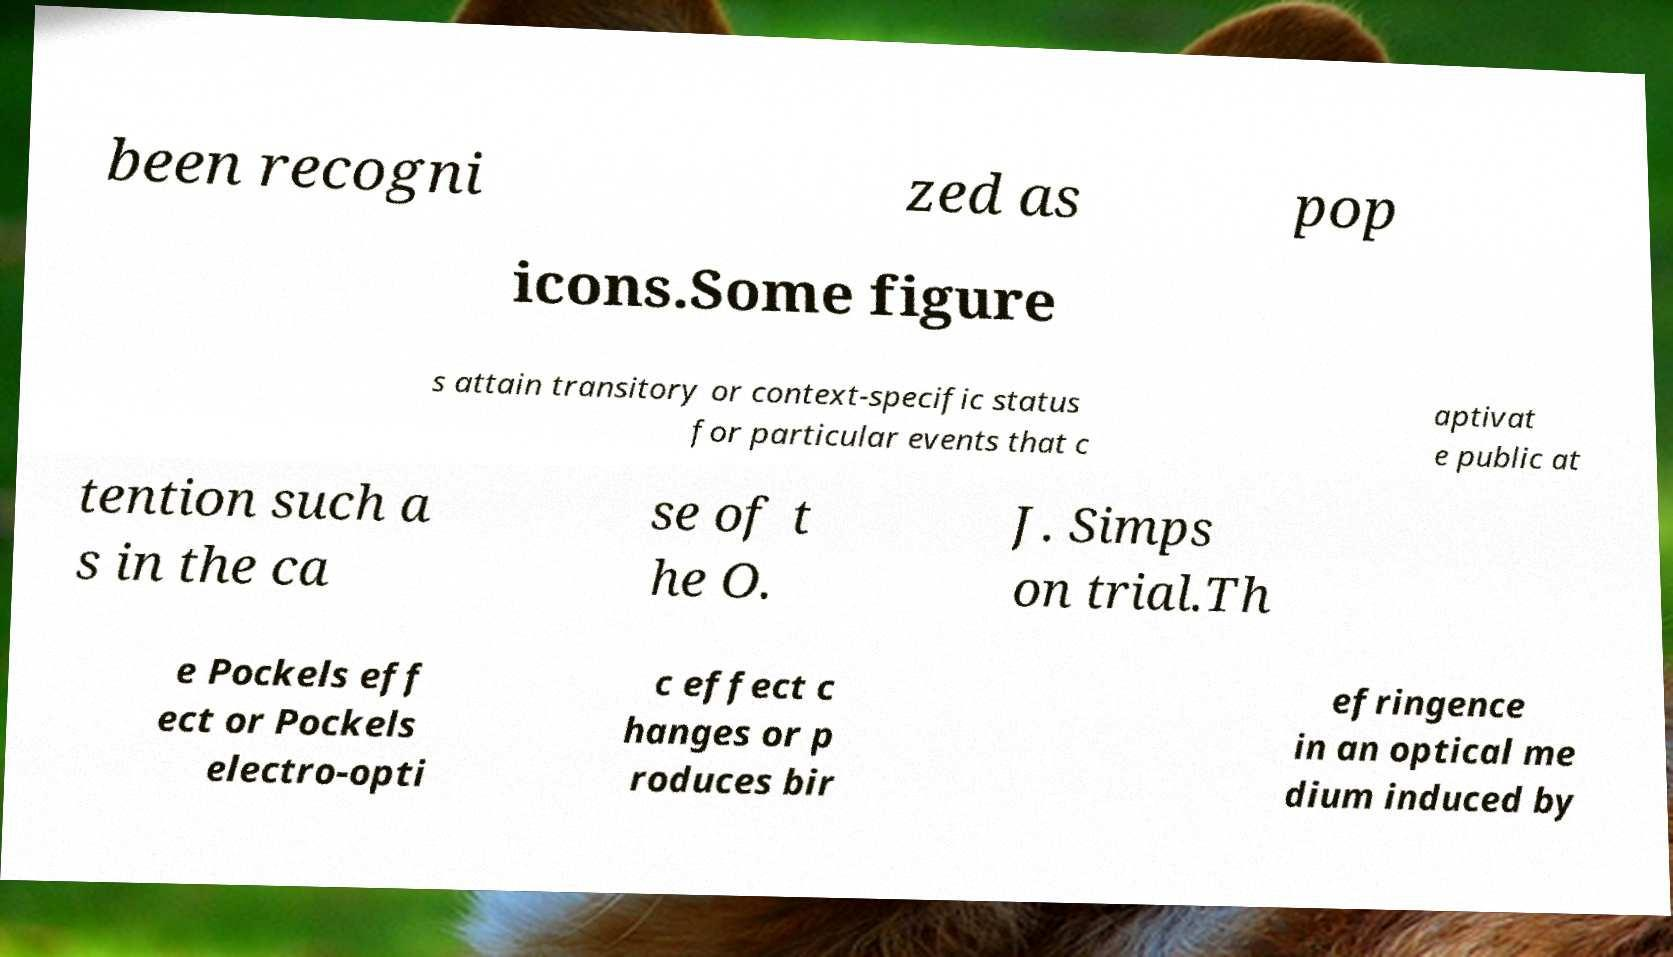Can you read and provide the text displayed in the image?This photo seems to have some interesting text. Can you extract and type it out for me? been recogni zed as pop icons.Some figure s attain transitory or context-specific status for particular events that c aptivat e public at tention such a s in the ca se of t he O. J. Simps on trial.Th e Pockels eff ect or Pockels electro-opti c effect c hanges or p roduces bir efringence in an optical me dium induced by 